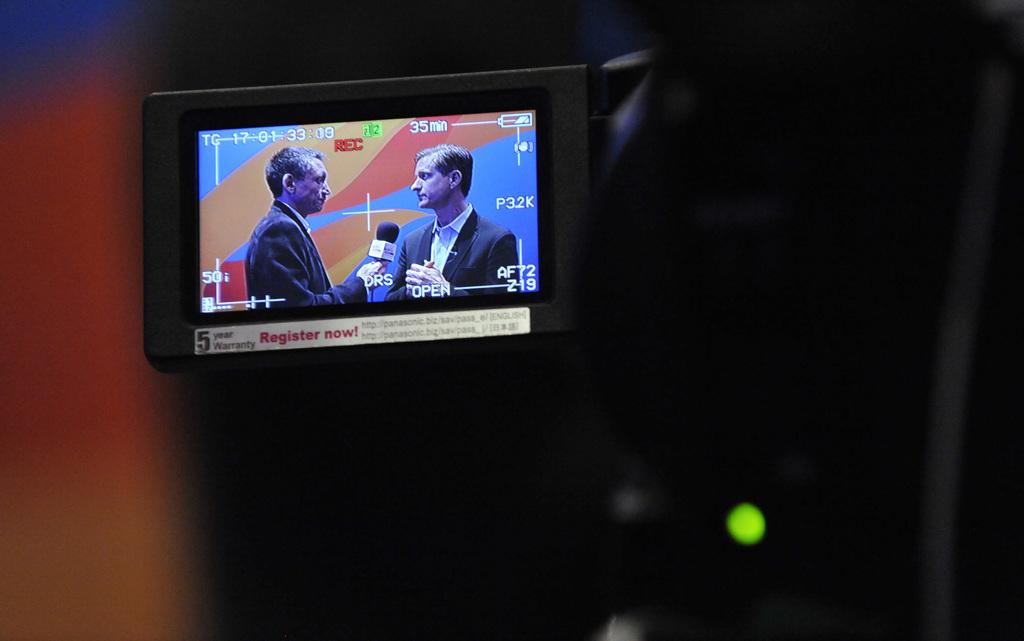What does it say below the monitor screen?
Provide a short and direct response. Register now. How many years of warranty?
Ensure brevity in your answer.  5. 